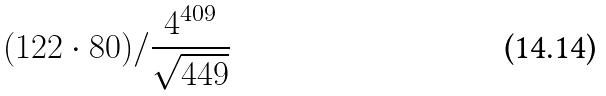Convert formula to latex. <formula><loc_0><loc_0><loc_500><loc_500>( 1 2 2 \cdot 8 0 ) / \frac { 4 ^ { 4 0 9 } } { \sqrt { 4 4 9 } }</formula> 